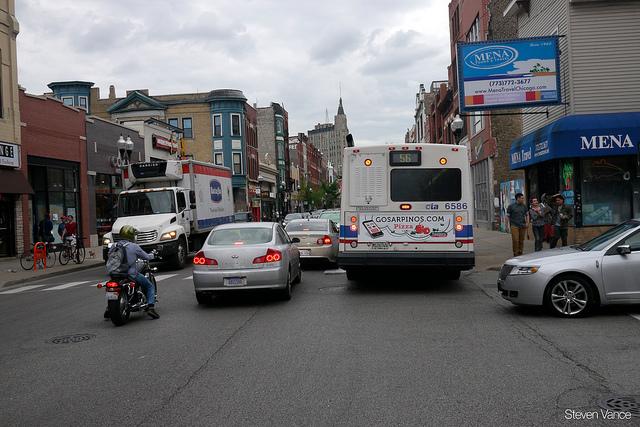What kind of vehicles are on the road?
Concise answer only. Cars, bus, truck, motorcycle. How many deckers is the bus?
Write a very short answer. 1. How many vehicles are on this street?
Write a very short answer. 9. Where are the people?
Short answer required. Sidewalk. Are there people walking on the crosswalk?
Keep it brief. No. 